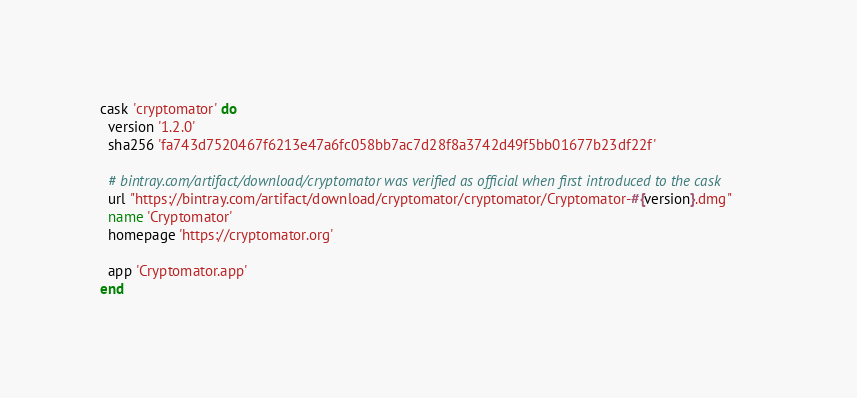<code> <loc_0><loc_0><loc_500><loc_500><_Ruby_>cask 'cryptomator' do
  version '1.2.0'
  sha256 'fa743d7520467f6213e47a6fc058bb7ac7d28f8a3742d49f5bb01677b23df22f'

  # bintray.com/artifact/download/cryptomator was verified as official when first introduced to the cask
  url "https://bintray.com/artifact/download/cryptomator/cryptomator/Cryptomator-#{version}.dmg"
  name 'Cryptomator'
  homepage 'https://cryptomator.org'

  app 'Cryptomator.app'
end
</code> 